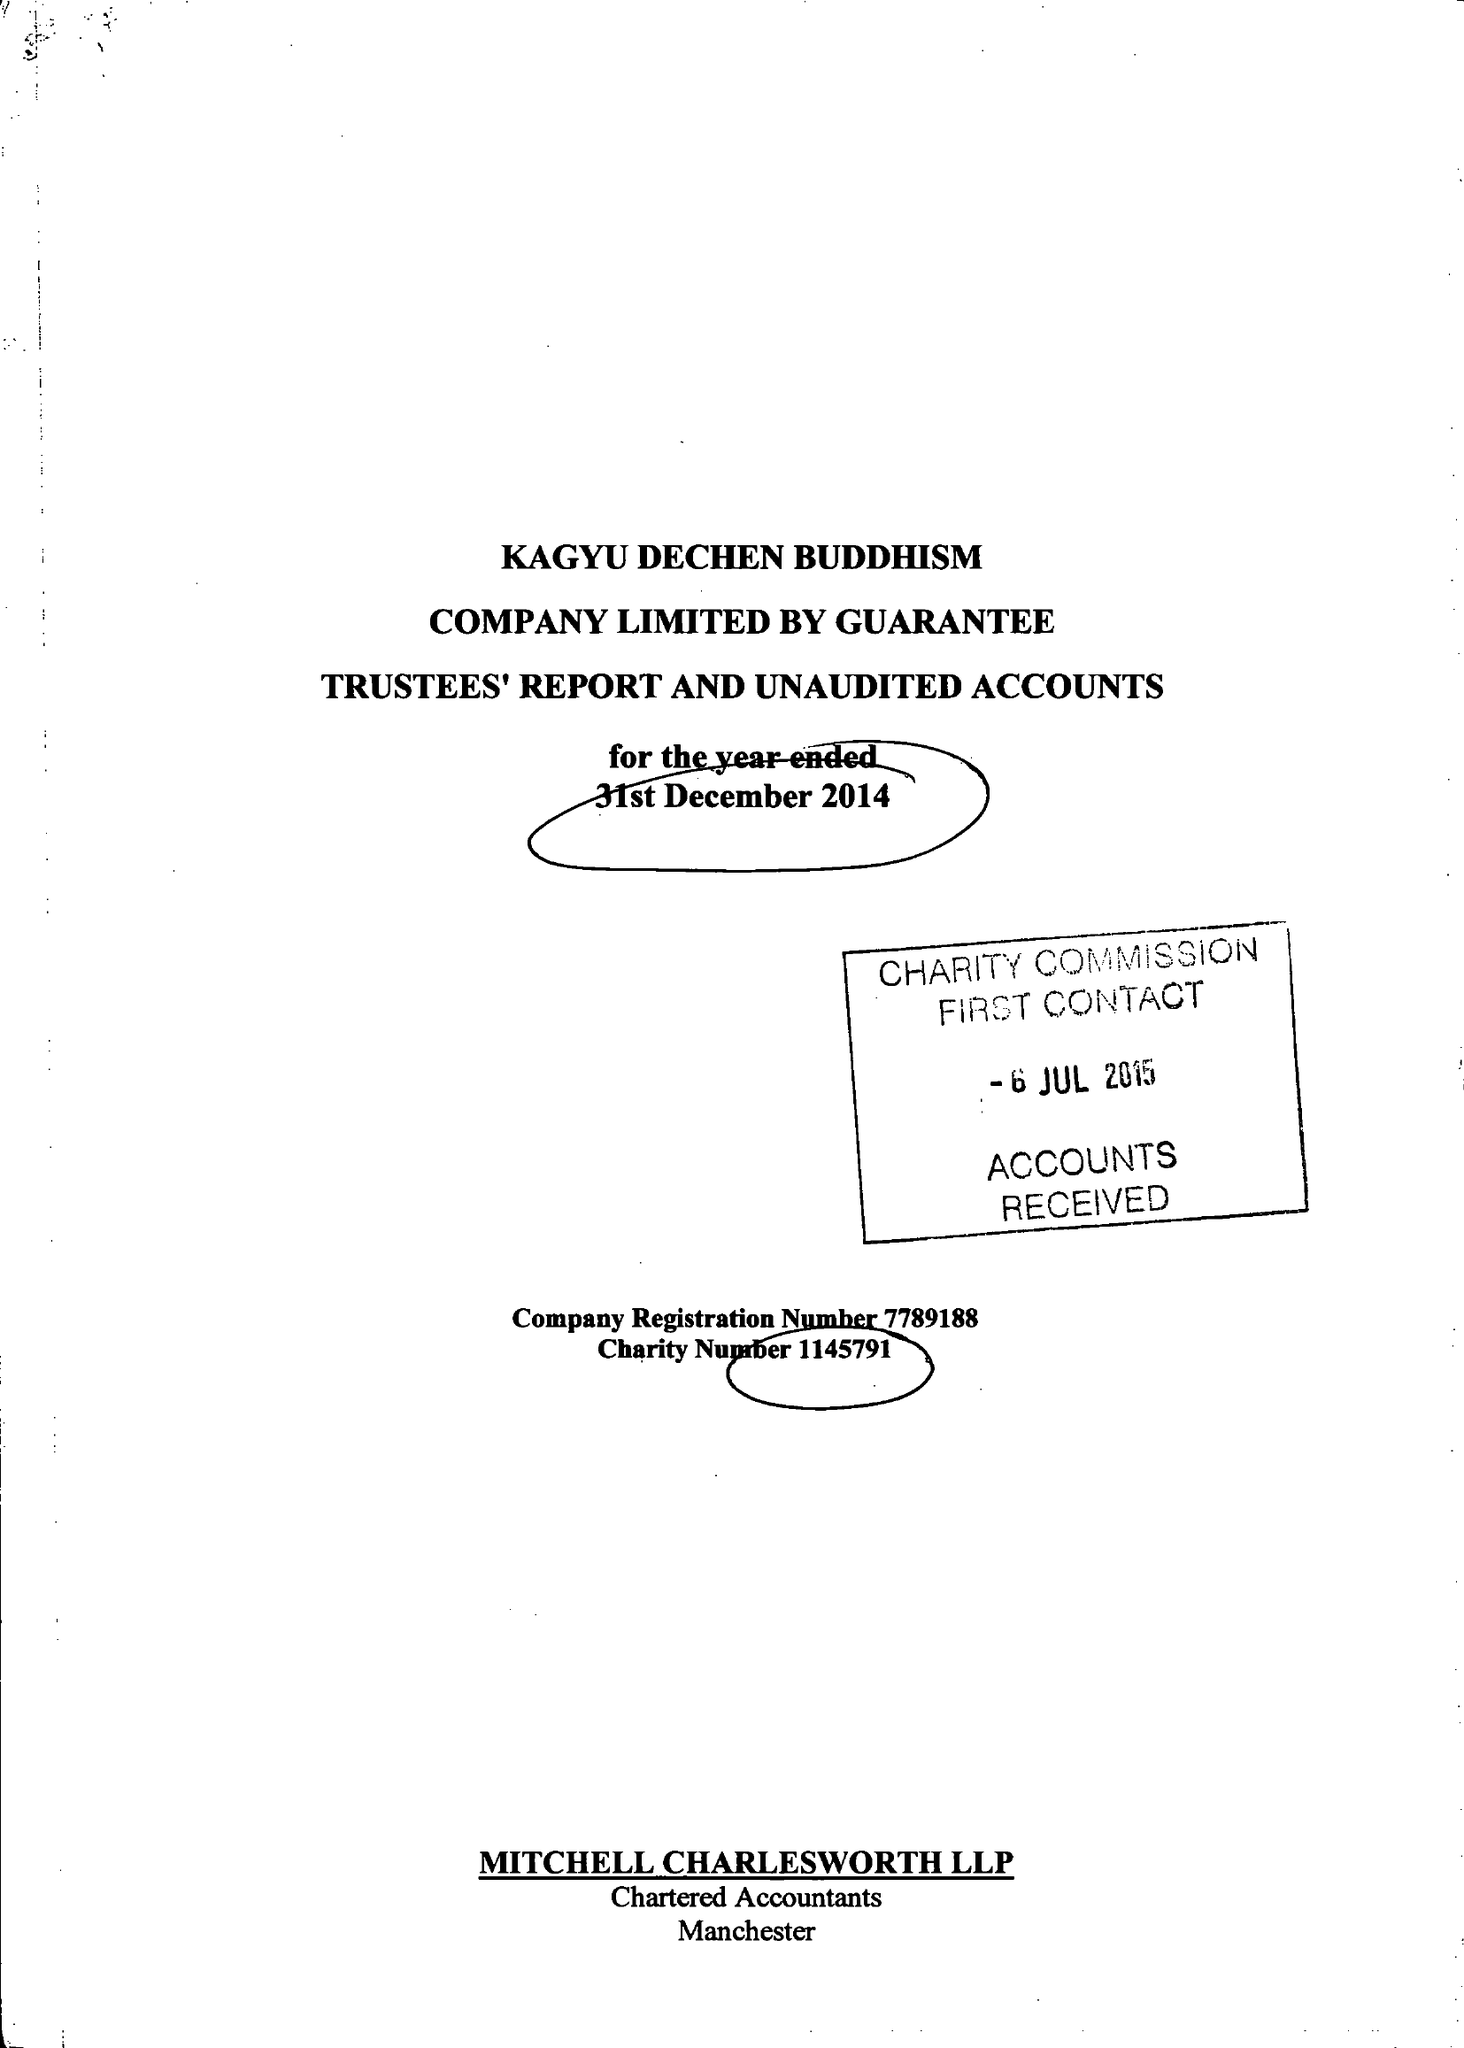What is the value for the report_date?
Answer the question using a single word or phrase. 2014-12-31 